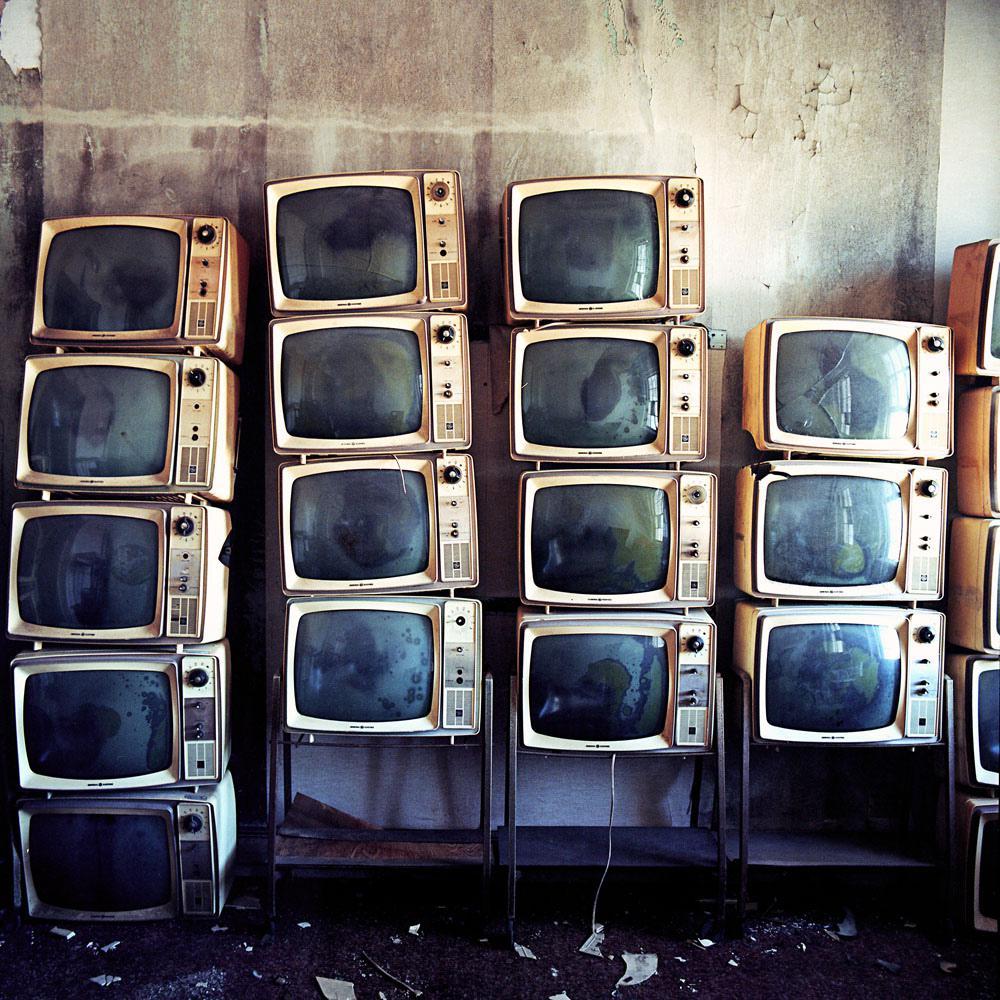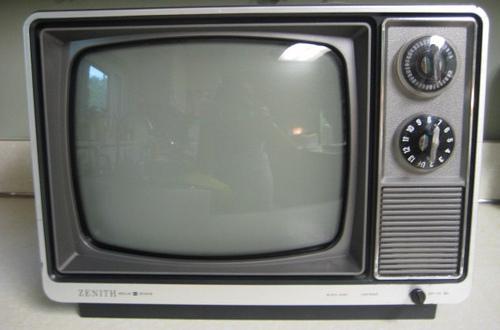The first image is the image on the left, the second image is the image on the right. Considering the images on both sides, is "There is exactly one television in the right image and multiple televisions in the left image." valid? Answer yes or no. Yes. The first image is the image on the left, the second image is the image on the right. For the images shown, is this caption "the right image contains 1 tv" true? Answer yes or no. Yes. 